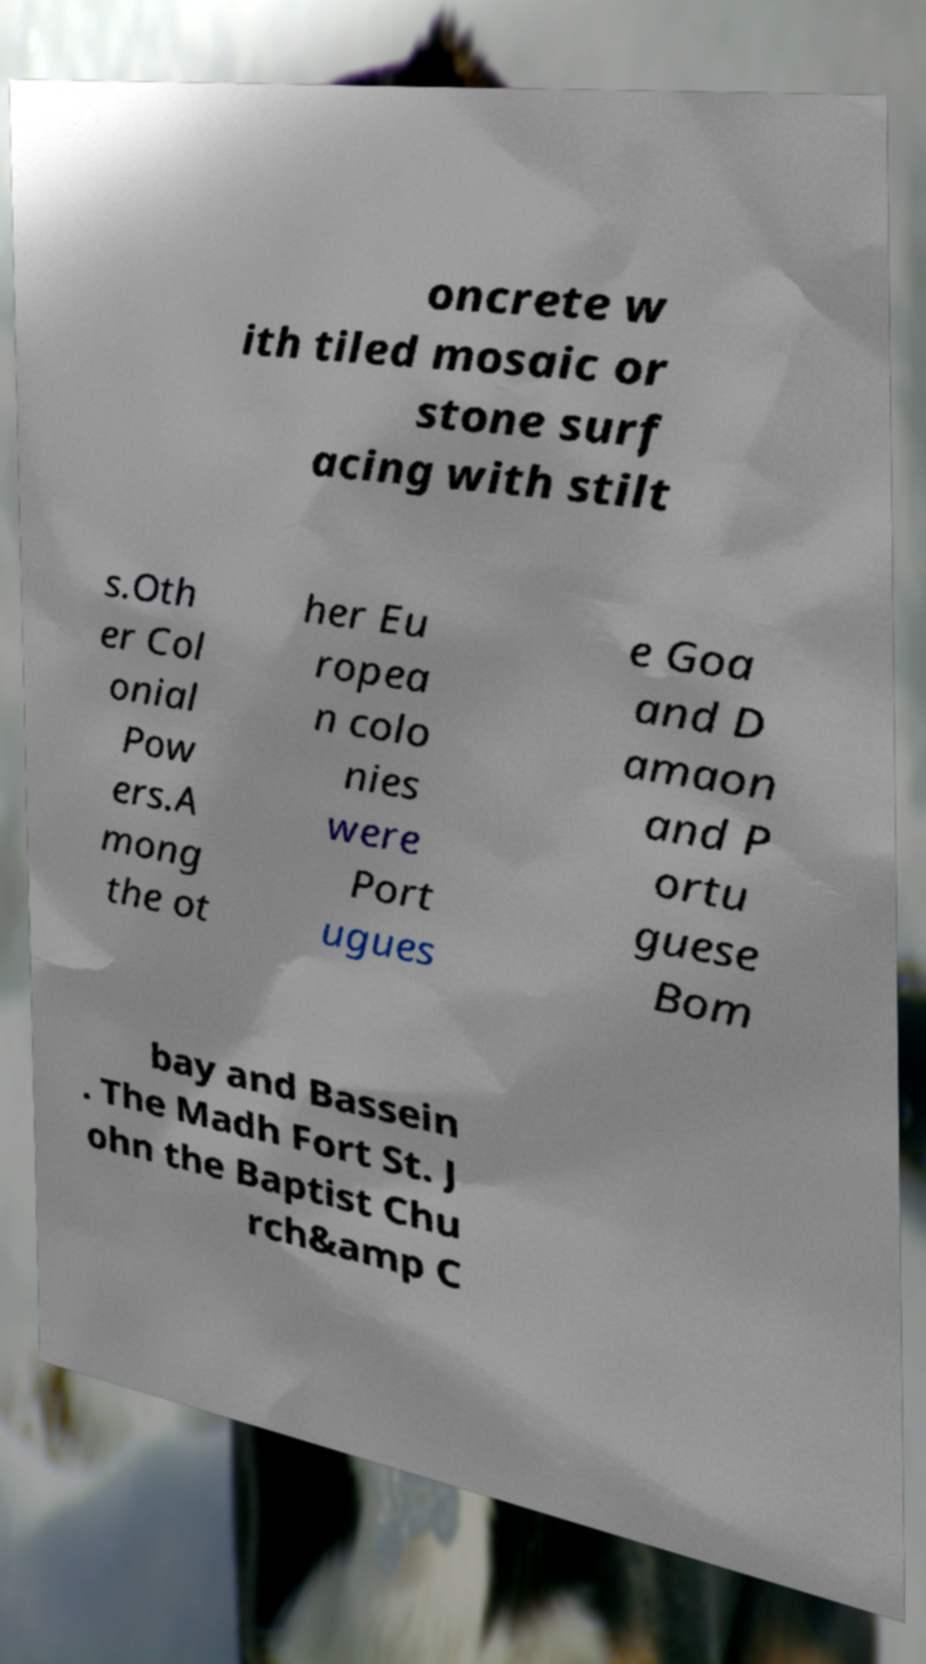Please identify and transcribe the text found in this image. oncrete w ith tiled mosaic or stone surf acing with stilt s.Oth er Col onial Pow ers.A mong the ot her Eu ropea n colo nies were Port ugues e Goa and D amaon and P ortu guese Bom bay and Bassein . The Madh Fort St. J ohn the Baptist Chu rch&amp C 